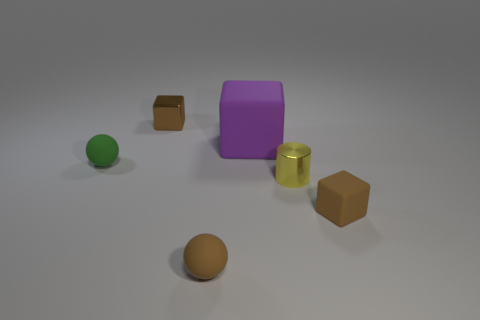Add 1 large purple things. How many objects exist? 7 Subtract all big purple blocks. How many blocks are left? 2 Subtract all green balls. How many brown blocks are left? 2 Subtract all spheres. How many objects are left? 4 Subtract 1 cubes. How many cubes are left? 2 Subtract all blue balls. Subtract all yellow blocks. How many balls are left? 2 Subtract all blocks. Subtract all small rubber objects. How many objects are left? 0 Add 1 yellow metallic objects. How many yellow metallic objects are left? 2 Add 4 yellow metal things. How many yellow metal things exist? 5 Subtract all brown cubes. How many cubes are left? 1 